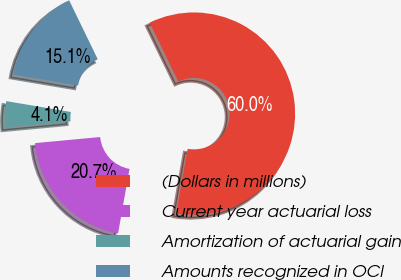<chart> <loc_0><loc_0><loc_500><loc_500><pie_chart><fcel>(Dollars in millions)<fcel>Current year actuarial loss<fcel>Amortization of actuarial gain<fcel>Amounts recognized in OCI<nl><fcel>59.99%<fcel>20.73%<fcel>4.14%<fcel>15.15%<nl></chart> 